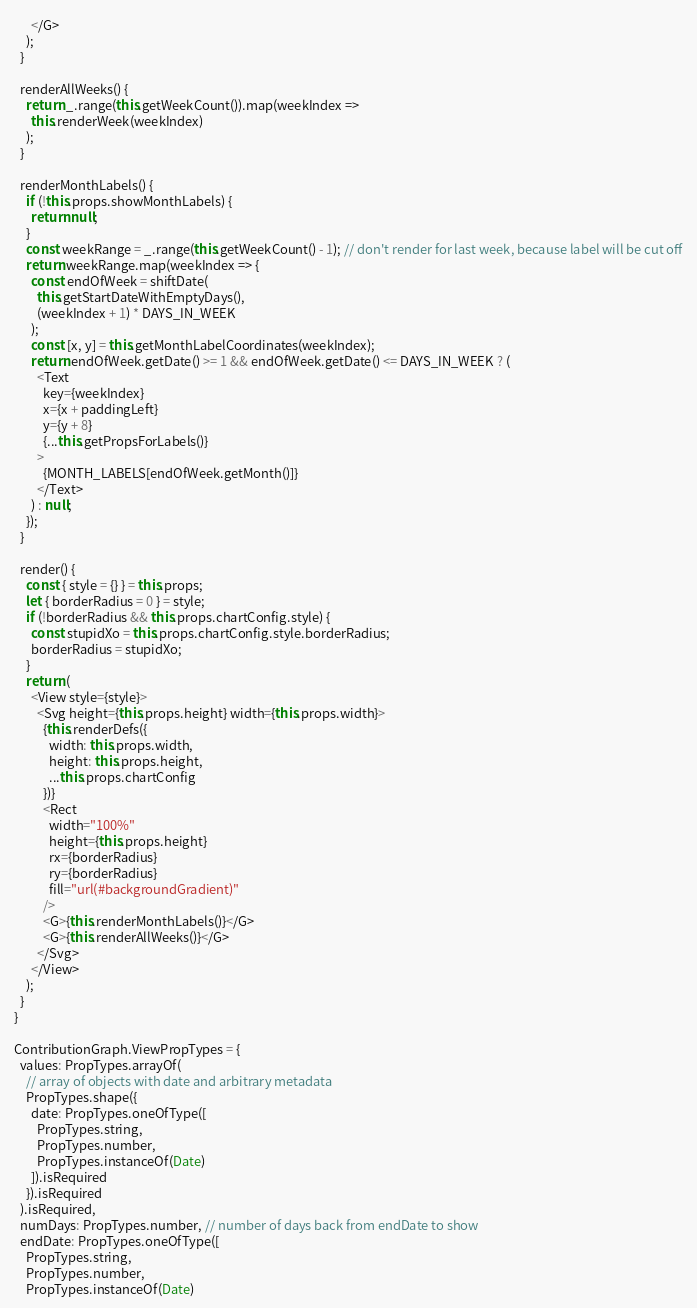<code> <loc_0><loc_0><loc_500><loc_500><_JavaScript_>      </G>
    );
  }

  renderAllWeeks() {
    return _.range(this.getWeekCount()).map(weekIndex =>
      this.renderWeek(weekIndex)
    );
  }

  renderMonthLabels() {
    if (!this.props.showMonthLabels) {
      return null;
    }
    const weekRange = _.range(this.getWeekCount() - 1); // don't render for last week, because label will be cut off
    return weekRange.map(weekIndex => {
      const endOfWeek = shiftDate(
        this.getStartDateWithEmptyDays(),
        (weekIndex + 1) * DAYS_IN_WEEK
      );
      const [x, y] = this.getMonthLabelCoordinates(weekIndex);
      return endOfWeek.getDate() >= 1 && endOfWeek.getDate() <= DAYS_IN_WEEK ? (
        <Text
          key={weekIndex}
          x={x + paddingLeft}
          y={y + 8}
          {...this.getPropsForLabels()}
        >
          {MONTH_LABELS[endOfWeek.getMonth()]}
        </Text>
      ) : null;
    });
  }

  render() {
    const { style = {} } = this.props;
    let { borderRadius = 0 } = style;
    if (!borderRadius && this.props.chartConfig.style) {
      const stupidXo = this.props.chartConfig.style.borderRadius;
      borderRadius = stupidXo;
    }
    return (
      <View style={style}>
        <Svg height={this.props.height} width={this.props.width}>
          {this.renderDefs({
            width: this.props.width,
            height: this.props.height,
            ...this.props.chartConfig
          })}
          <Rect
            width="100%"
            height={this.props.height}
            rx={borderRadius}
            ry={borderRadius}
            fill="url(#backgroundGradient)"
          />
          <G>{this.renderMonthLabels()}</G>
          <G>{this.renderAllWeeks()}</G>
        </Svg>
      </View>
    );
  }
}

ContributionGraph.ViewPropTypes = {
  values: PropTypes.arrayOf(
    // array of objects with date and arbitrary metadata
    PropTypes.shape({
      date: PropTypes.oneOfType([
        PropTypes.string,
        PropTypes.number,
        PropTypes.instanceOf(Date)
      ]).isRequired
    }).isRequired
  ).isRequired,
  numDays: PropTypes.number, // number of days back from endDate to show
  endDate: PropTypes.oneOfType([
    PropTypes.string,
    PropTypes.number,
    PropTypes.instanceOf(Date)</code> 